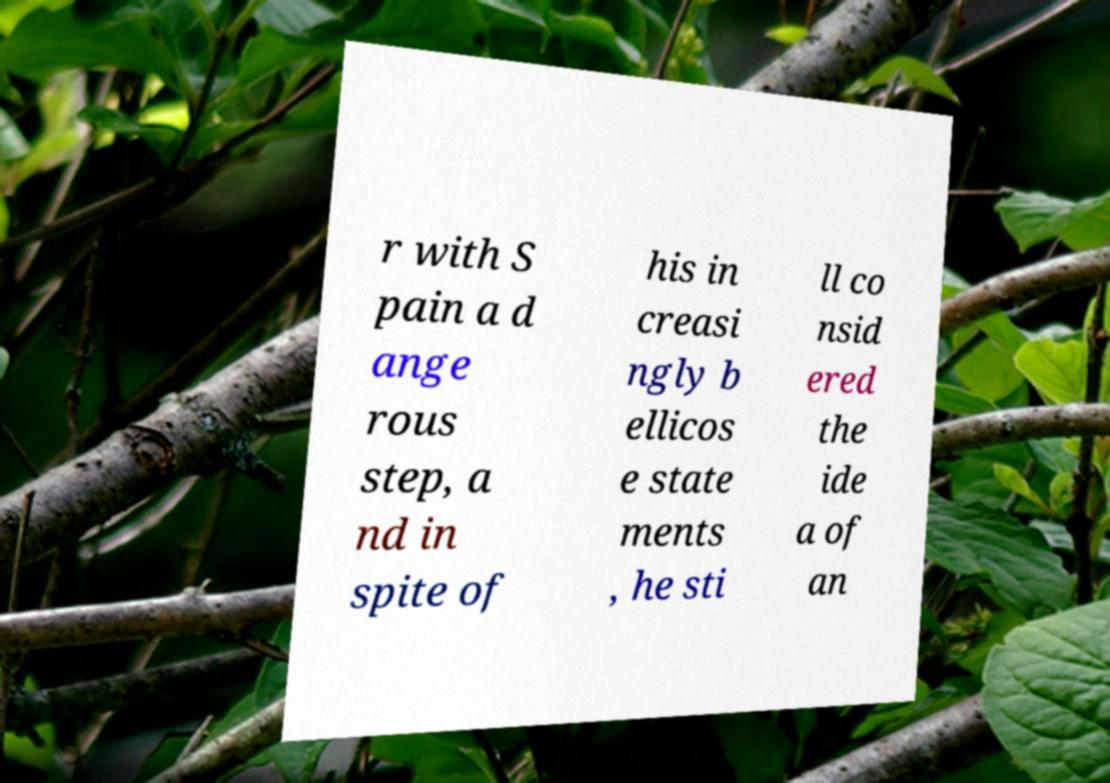I need the written content from this picture converted into text. Can you do that? r with S pain a d ange rous step, a nd in spite of his in creasi ngly b ellicos e state ments , he sti ll co nsid ered the ide a of an 